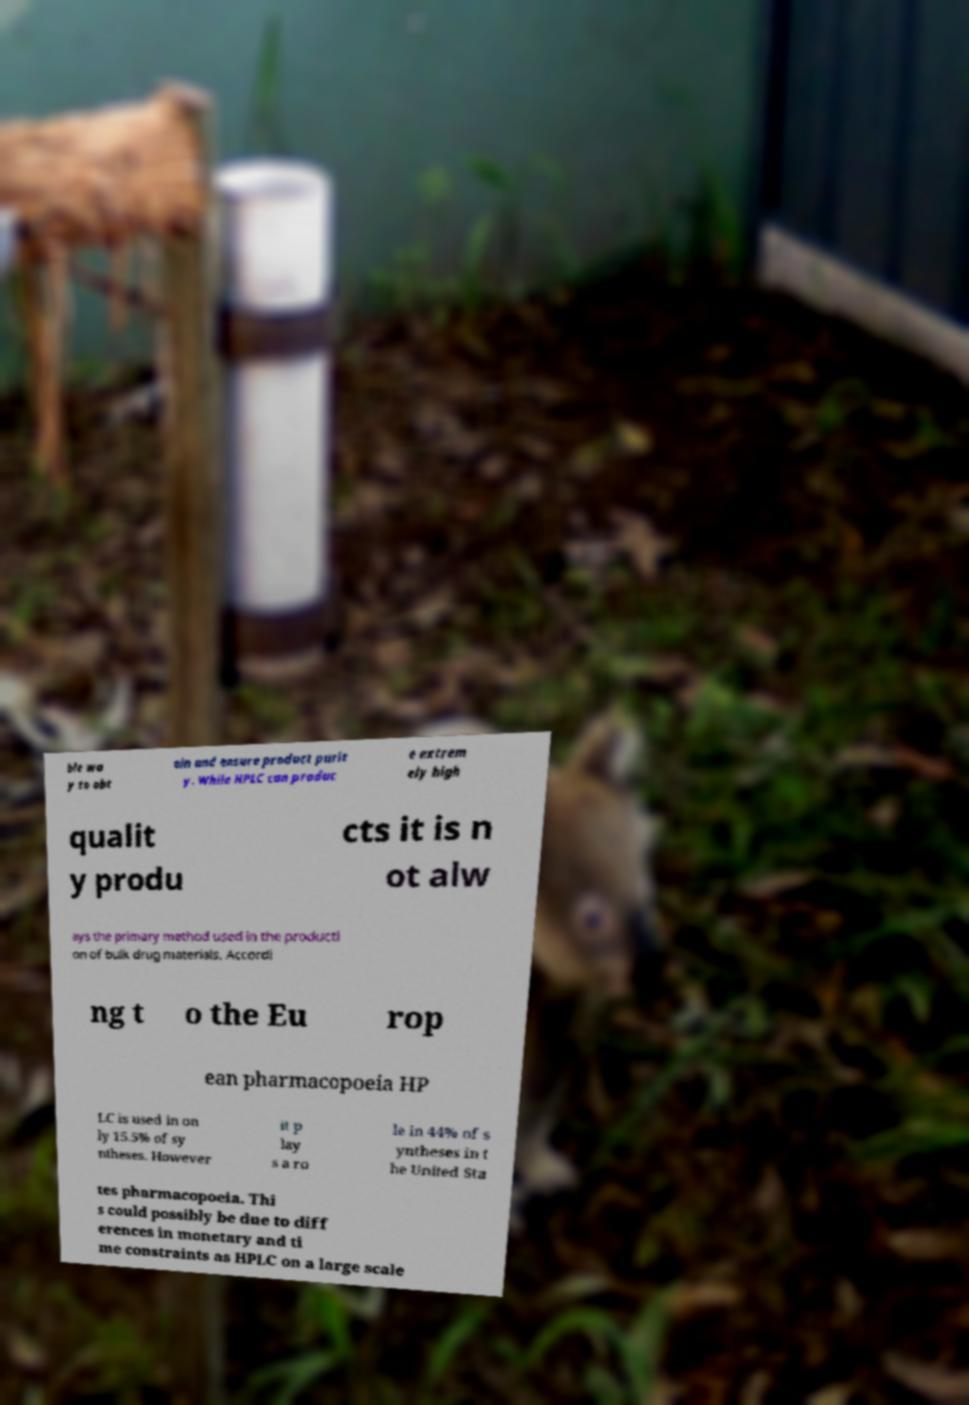Can you read and provide the text displayed in the image?This photo seems to have some interesting text. Can you extract and type it out for me? ble wa y to obt ain and ensure product purit y. While HPLC can produc e extrem ely high qualit y produ cts it is n ot alw ays the primary method used in the producti on of bulk drug materials. Accordi ng t o the Eu rop ean pharmacopoeia HP LC is used in on ly 15.5% of sy ntheses. However it p lay s a ro le in 44% of s yntheses in t he United Sta tes pharmacopoeia. Thi s could possibly be due to diff erences in monetary and ti me constraints as HPLC on a large scale 